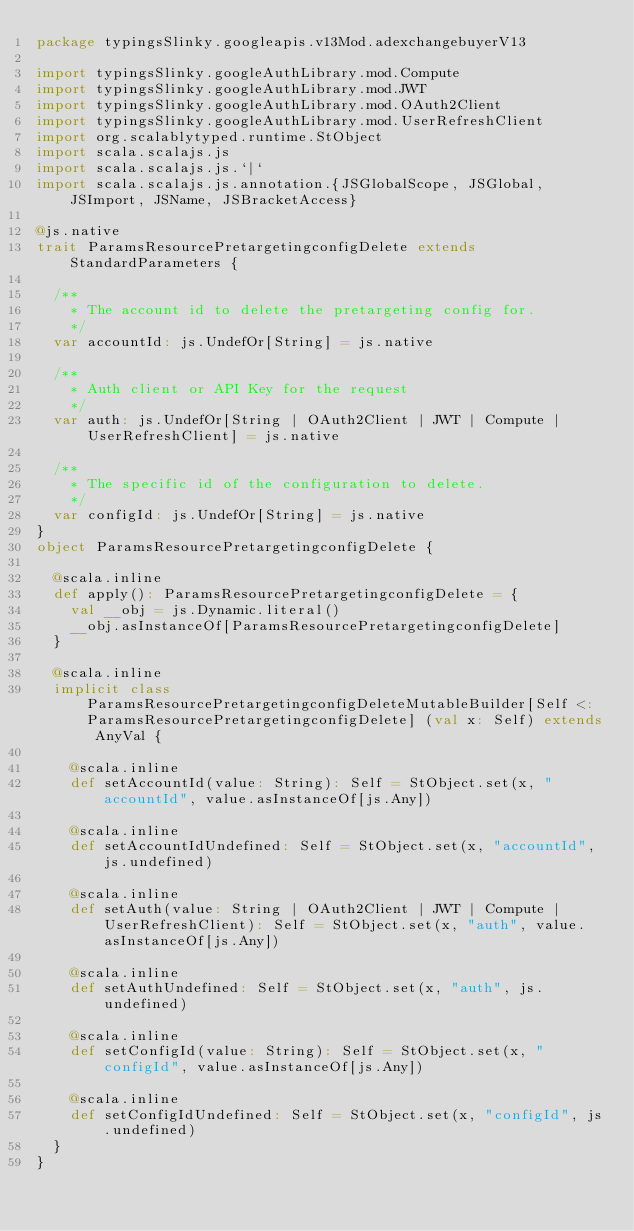<code> <loc_0><loc_0><loc_500><loc_500><_Scala_>package typingsSlinky.googleapis.v13Mod.adexchangebuyerV13

import typingsSlinky.googleAuthLibrary.mod.Compute
import typingsSlinky.googleAuthLibrary.mod.JWT
import typingsSlinky.googleAuthLibrary.mod.OAuth2Client
import typingsSlinky.googleAuthLibrary.mod.UserRefreshClient
import org.scalablytyped.runtime.StObject
import scala.scalajs.js
import scala.scalajs.js.`|`
import scala.scalajs.js.annotation.{JSGlobalScope, JSGlobal, JSImport, JSName, JSBracketAccess}

@js.native
trait ParamsResourcePretargetingconfigDelete extends StandardParameters {
  
  /**
    * The account id to delete the pretargeting config for.
    */
  var accountId: js.UndefOr[String] = js.native
  
  /**
    * Auth client or API Key for the request
    */
  var auth: js.UndefOr[String | OAuth2Client | JWT | Compute | UserRefreshClient] = js.native
  
  /**
    * The specific id of the configuration to delete.
    */
  var configId: js.UndefOr[String] = js.native
}
object ParamsResourcePretargetingconfigDelete {
  
  @scala.inline
  def apply(): ParamsResourcePretargetingconfigDelete = {
    val __obj = js.Dynamic.literal()
    __obj.asInstanceOf[ParamsResourcePretargetingconfigDelete]
  }
  
  @scala.inline
  implicit class ParamsResourcePretargetingconfigDeleteMutableBuilder[Self <: ParamsResourcePretargetingconfigDelete] (val x: Self) extends AnyVal {
    
    @scala.inline
    def setAccountId(value: String): Self = StObject.set(x, "accountId", value.asInstanceOf[js.Any])
    
    @scala.inline
    def setAccountIdUndefined: Self = StObject.set(x, "accountId", js.undefined)
    
    @scala.inline
    def setAuth(value: String | OAuth2Client | JWT | Compute | UserRefreshClient): Self = StObject.set(x, "auth", value.asInstanceOf[js.Any])
    
    @scala.inline
    def setAuthUndefined: Self = StObject.set(x, "auth", js.undefined)
    
    @scala.inline
    def setConfigId(value: String): Self = StObject.set(x, "configId", value.asInstanceOf[js.Any])
    
    @scala.inline
    def setConfigIdUndefined: Self = StObject.set(x, "configId", js.undefined)
  }
}
</code> 